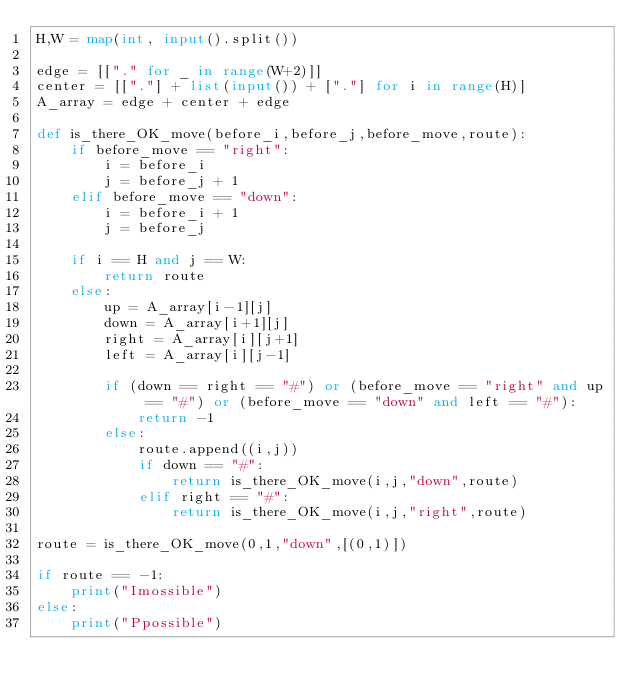Convert code to text. <code><loc_0><loc_0><loc_500><loc_500><_Python_>H,W = map(int, input().split())

edge = [["." for _ in range(W+2)]]
center = [["."] + list(input()) + ["."] for i in range(H)]
A_array = edge + center + edge

def is_there_OK_move(before_i,before_j,before_move,route):
    if before_move == "right":
        i = before_i
        j = before_j + 1
    elif before_move == "down":
        i = before_i + 1
        j = before_j
    
    if i == H and j == W:
        return route
    else:
        up = A_array[i-1][j]
        down = A_array[i+1][j]
        right = A_array[i][j+1]
        left = A_array[i][j-1]

        if (down == right == "#") or (before_move == "right" and up == "#") or (before_move == "down" and left == "#"):
            return -1
        else:
            route.append((i,j))
            if down == "#":
                return is_there_OK_move(i,j,"down",route)
            elif right == "#":
                return is_there_OK_move(i,j,"right",route)

route = is_there_OK_move(0,1,"down",[(0,1)])

if route == -1:
    print("Imossible")
else:           
    print("Ppossible")</code> 